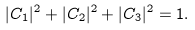Convert formula to latex. <formula><loc_0><loc_0><loc_500><loc_500>| C _ { 1 } | ^ { 2 } + | C _ { 2 } | ^ { 2 } + | C _ { 3 } | ^ { 2 } = 1 .</formula> 